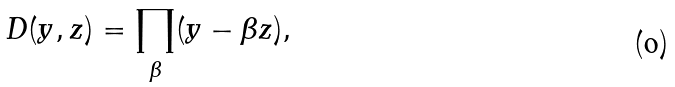Convert formula to latex. <formula><loc_0><loc_0><loc_500><loc_500>D ( y , z ) = \prod _ { \beta } ( y - \beta z ) ,</formula> 